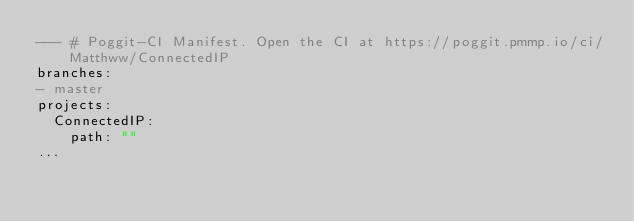Convert code to text. <code><loc_0><loc_0><loc_500><loc_500><_YAML_>--- # Poggit-CI Manifest. Open the CI at https://poggit.pmmp.io/ci/Matthww/ConnectedIP
branches:
- master
projects:
  ConnectedIP:
    path: ""
...
</code> 